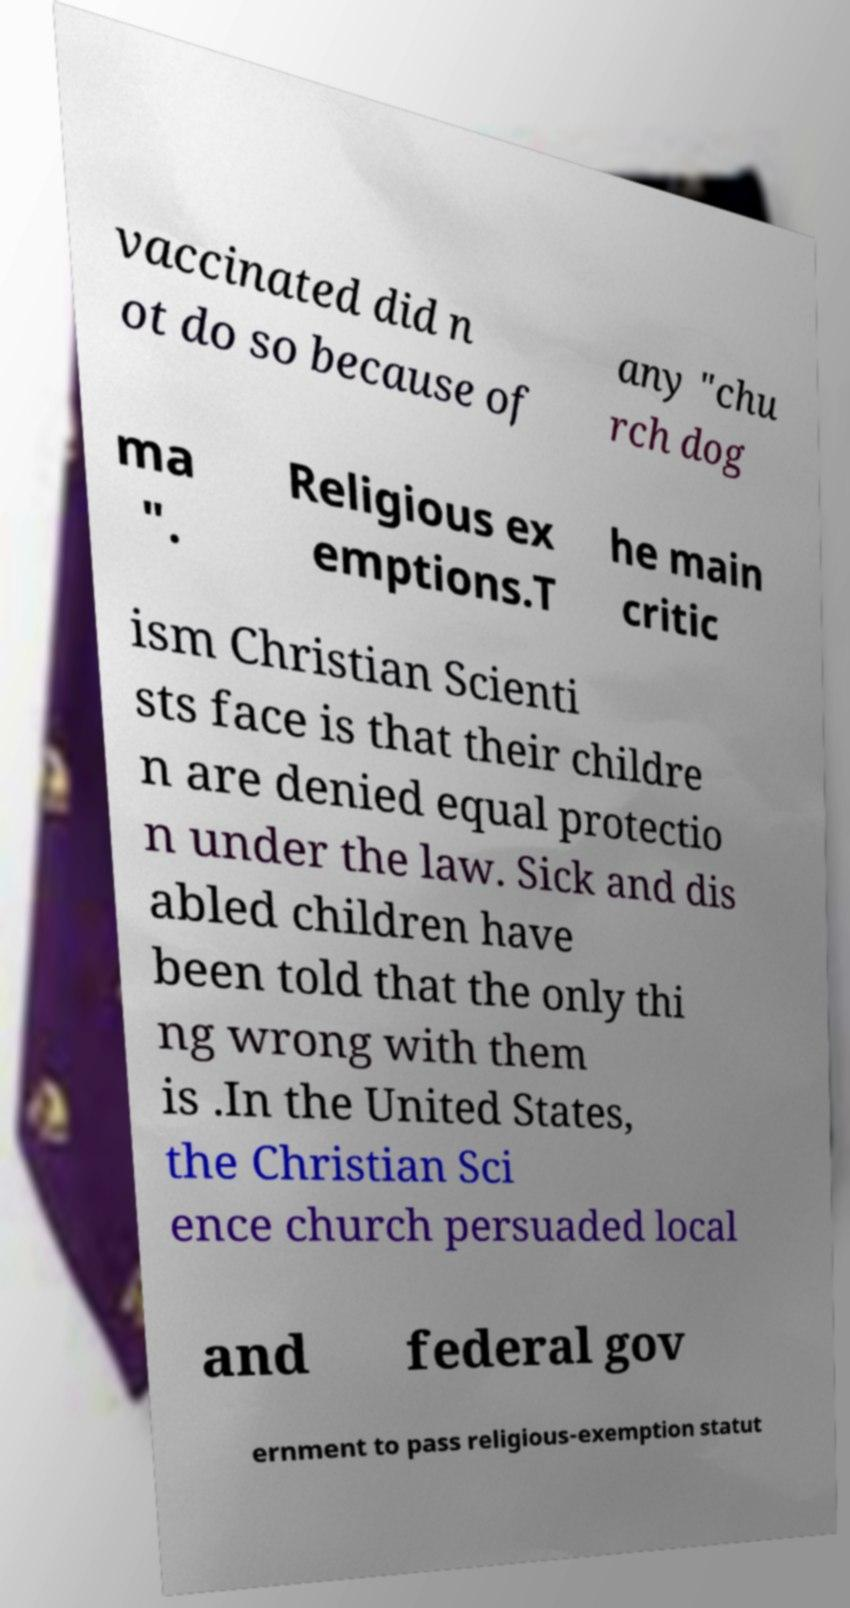For documentation purposes, I need the text within this image transcribed. Could you provide that? vaccinated did n ot do so because of any "chu rch dog ma ". Religious ex emptions.T he main critic ism Christian Scienti sts face is that their childre n are denied equal protectio n under the law. Sick and dis abled children have been told that the only thi ng wrong with them is .In the United States, the Christian Sci ence church persuaded local and federal gov ernment to pass religious-exemption statut 